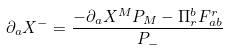Convert formula to latex. <formula><loc_0><loc_0><loc_500><loc_500>\partial _ { a } X ^ { - } = \frac { - \partial _ { a } X ^ { M } P _ { M } - \Pi _ { r } ^ { b } F _ { a b } ^ { r } } { P _ { - } }</formula> 